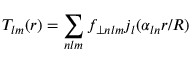Convert formula to latex. <formula><loc_0><loc_0><loc_500><loc_500>T _ { l m } ( r ) = \sum _ { n l m } f _ { \perp n l m } j _ { l } ( \alpha _ { \ln } r / R )</formula> 